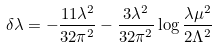Convert formula to latex. <formula><loc_0><loc_0><loc_500><loc_500>\delta \lambda = - \frac { 1 1 \lambda ^ { 2 } } { 3 2 \pi ^ { 2 } } - \frac { 3 \lambda ^ { 2 } } { 3 2 \pi ^ { 2 } } \log \frac { \lambda \mu ^ { 2 } } { 2 \Lambda ^ { 2 } }</formula> 